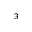Convert formula to latex. <formula><loc_0><loc_0><loc_500><loc_500>^ { 3 }</formula> 